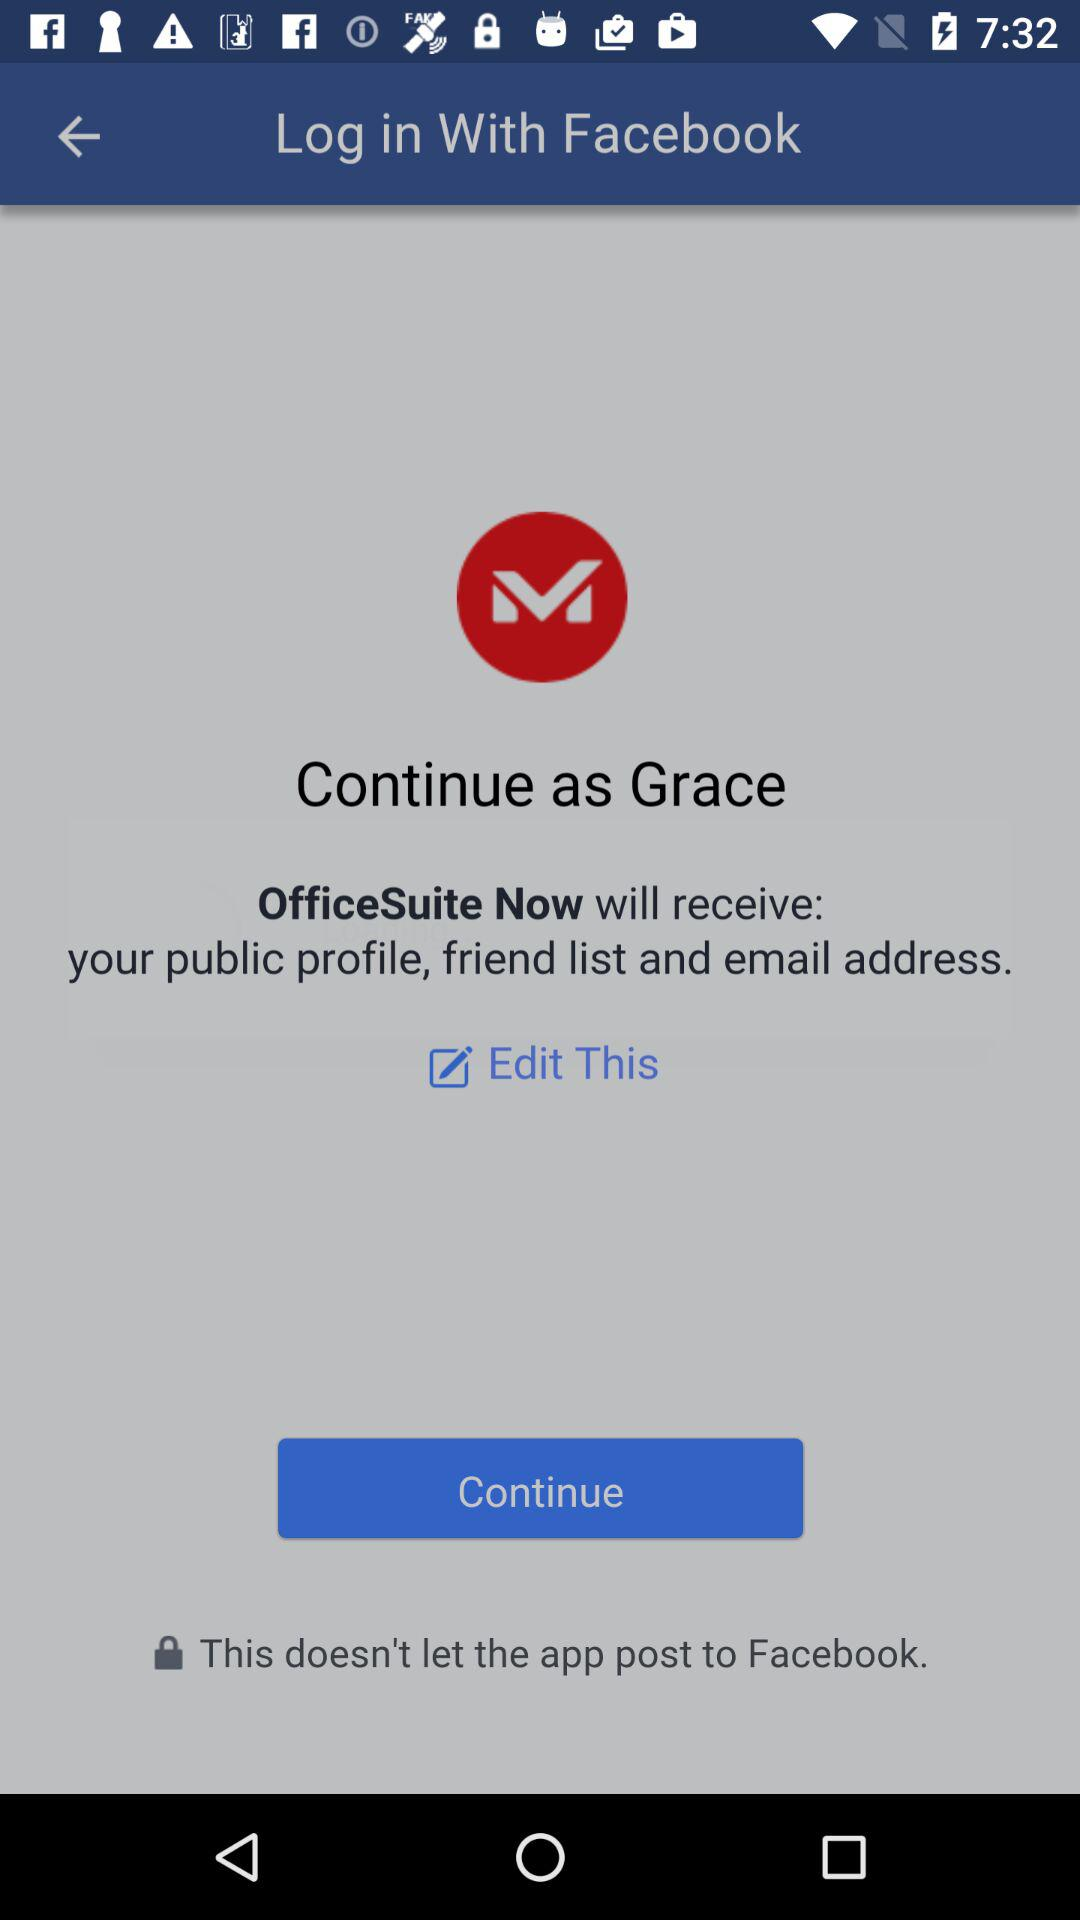Who will receive the public profile and email address? The public profile and email address will be received by "OfficeSuite Now". 